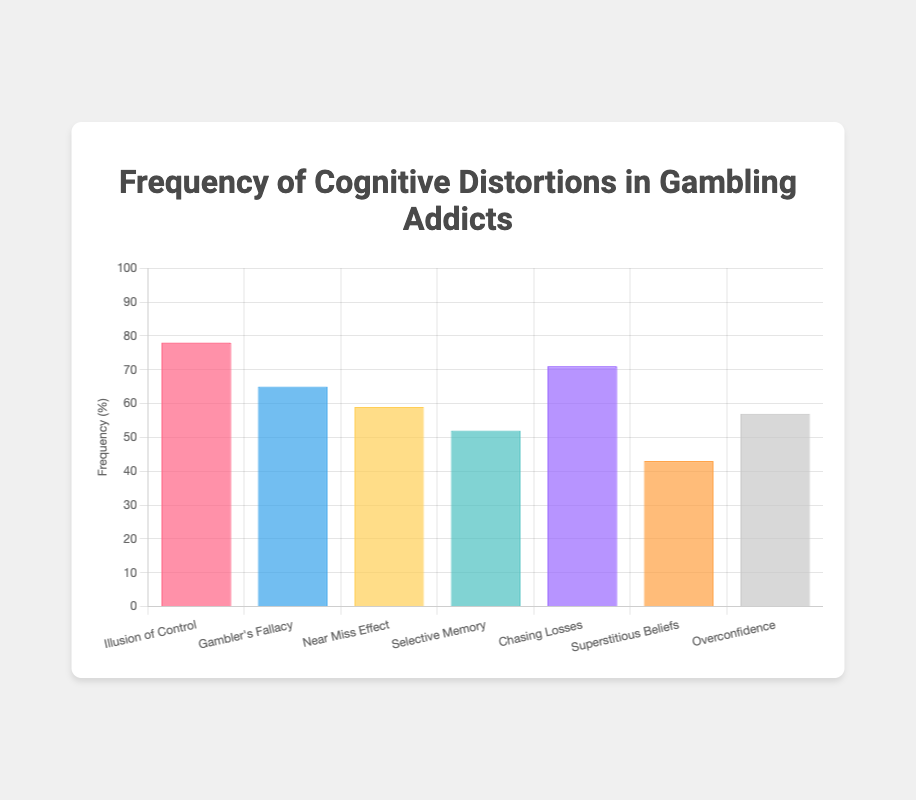What's the title of the figure? The title is the text at the top of the figure. It is clearly displayed in the center of the page.
Answer: Frequency of Cognitive Distortions in Gambling Addicts How many types of cognitive distortions are shown in the figure? Count the distinct items listed along the x-axis or in the legend.
Answer: 7 Which cognitive distortion has the highest frequency? Look for the tallest bar in the bar chart.
Answer: Illusion of Control What is the frequency of the 'Gambler's Fallacy' distortion, and which emoji represents it? Find the bar labeled 'Gambler's Fallacy' and check its height, then refer to the legend or tooltip to see the associated emoji.
Answer: 65%, 🔄 What is the combined frequency of 'Selective Memory' and 'Superstitious Beliefs'? Add the frequencies of 'Selective Memory' (52%) and 'Superstitious Beliefs' (43%).
Answer: 95% Is the frequency of 'Overconfidence' greater than 'Near Miss Effect'? Compare the heights of the bars labeled 'Overconfidence' (57%) and 'Near Miss Effect' (59%).
Answer: No What is the difference in frequency between 'Chasing Losses' and 'Superstitious Beliefs'? Subtract the frequency of 'Superstitious Beliefs' (43%) from 'Chasing Losses' (71%).
Answer: 28% Which cognitive distortion is represented with the 🍀 emoji and what is its frequency? Locate the 🍀 emoji in the data set or tooltip and find the corresponding cognitive distortion and its frequency.
Answer: Superstitious Beliefs, 43% What is the average frequency of all the cognitive distortions shown? Sum all frequencies (78 + 65 + 59 + 52 + 71 + 43 + 57), then divide by the number of distortions (7). (425 / 7 ≈ 60.71)
Answer: ≈ 60.71% Which cognitive distortion has the lowest frequency? Identify the shortest bar in the chart and read its label.
Answer: Superstitious Beliefs 